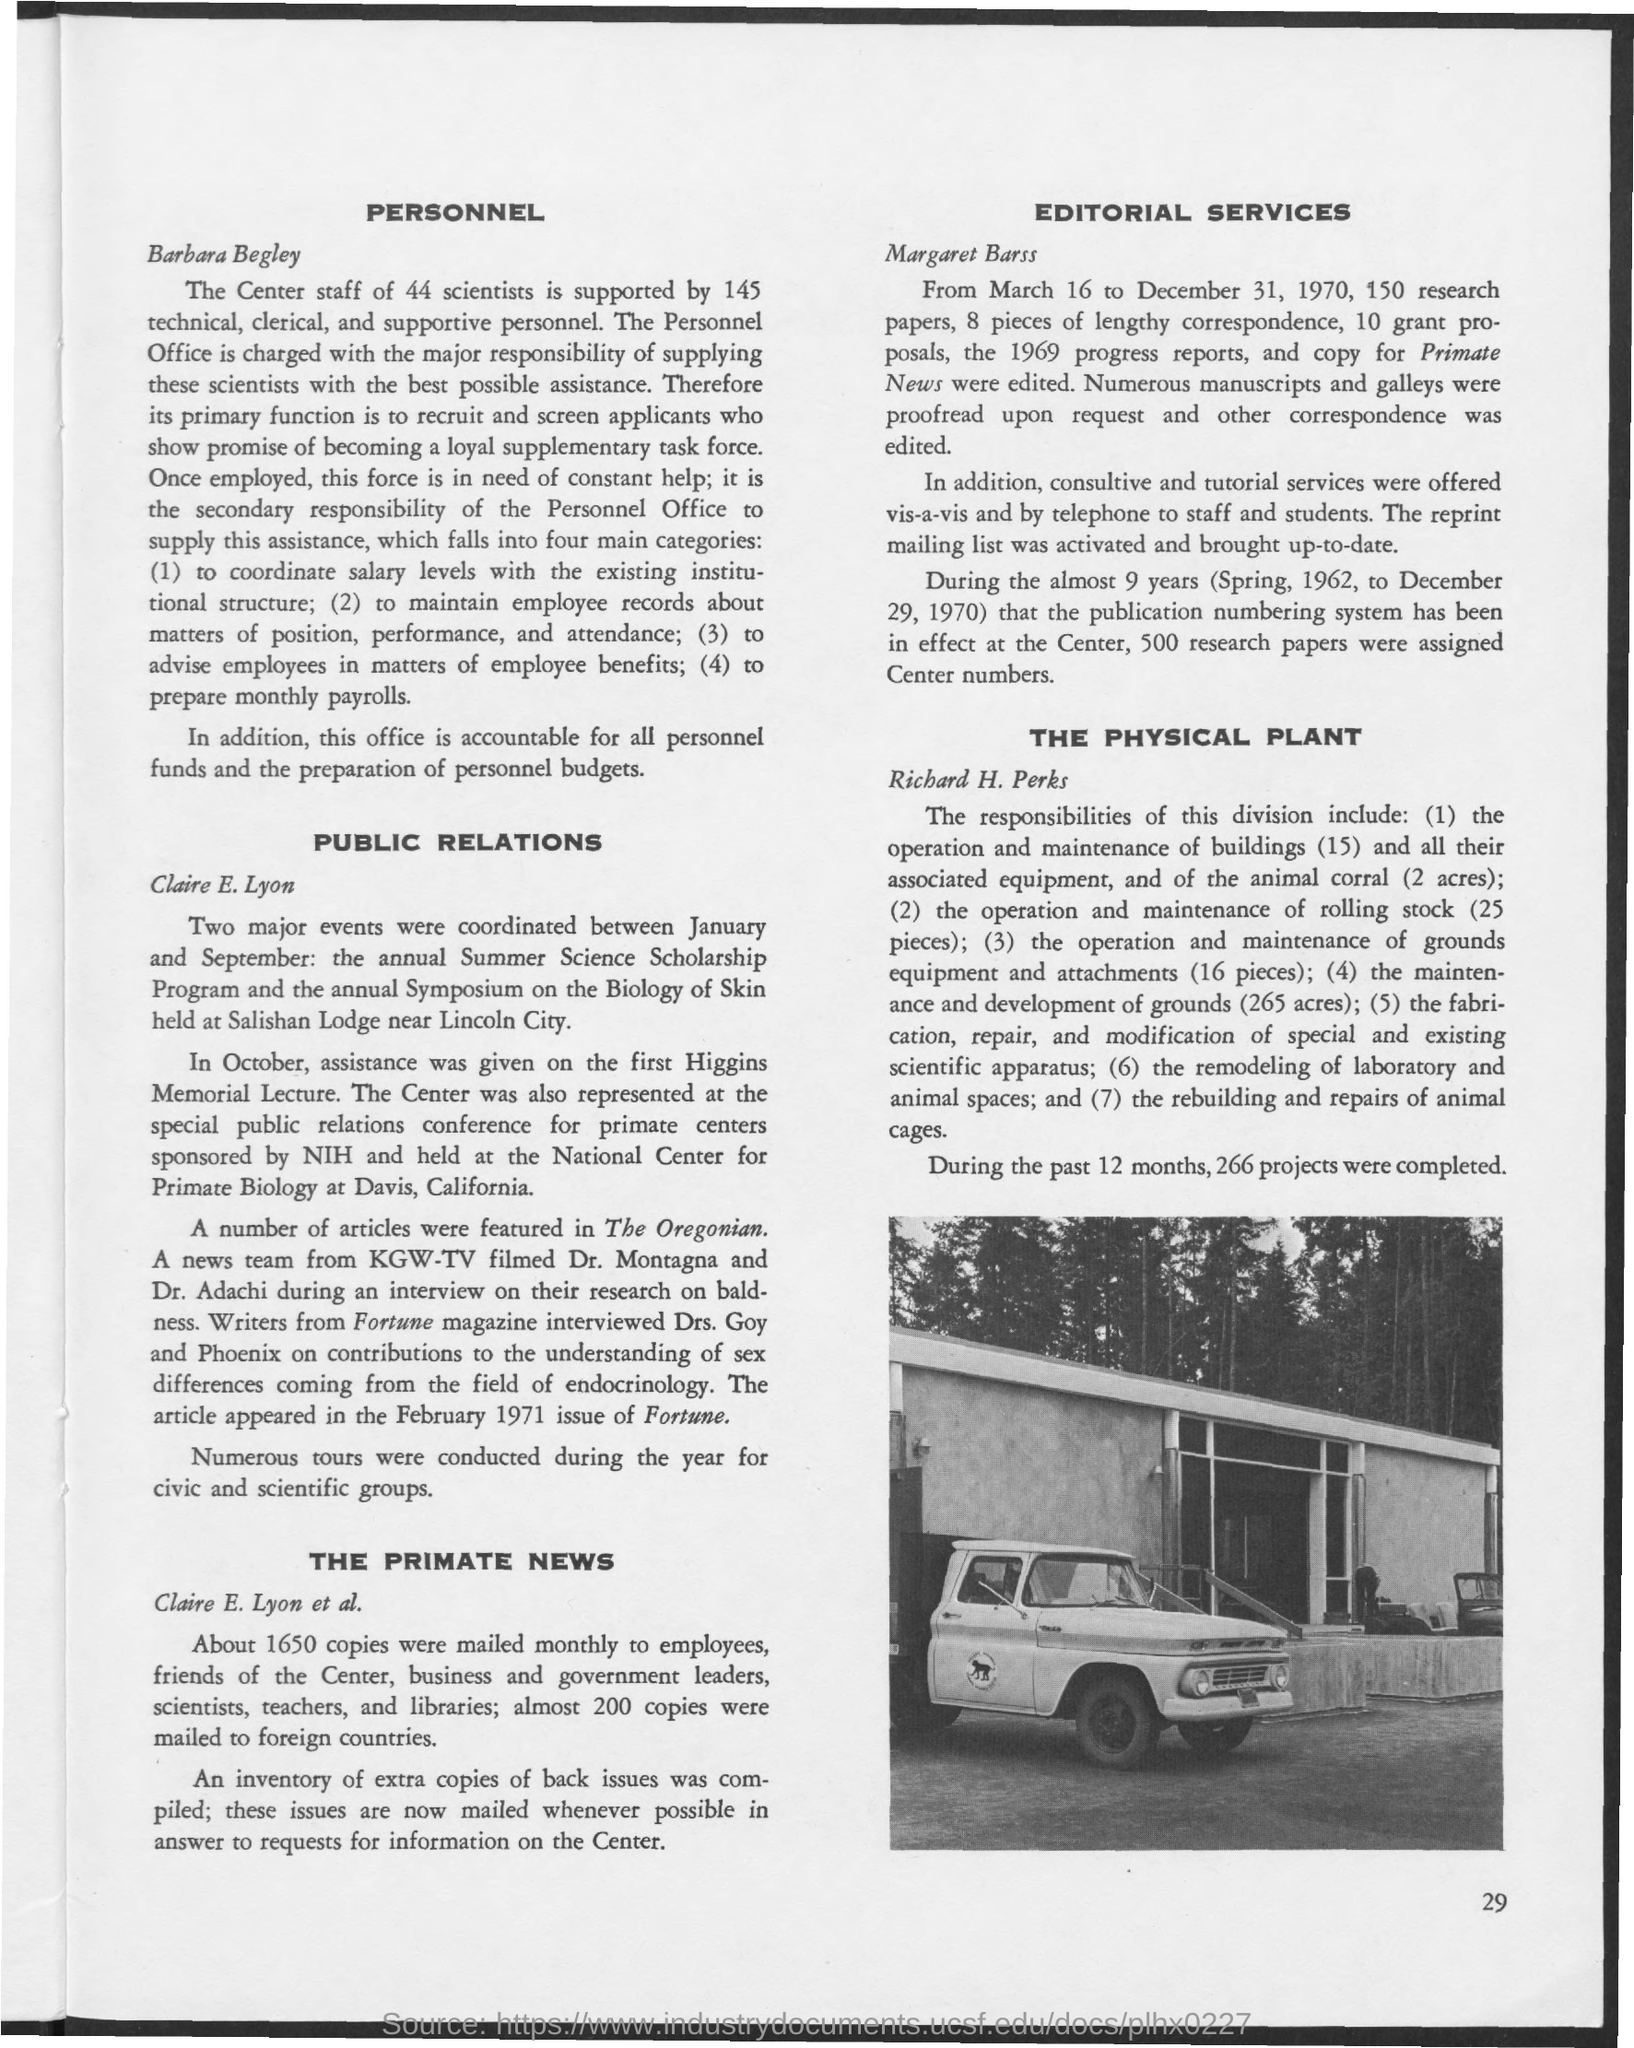What is the page number given at the right bottom corner of the page?
Ensure brevity in your answer.  29. How many scientists are there as "Center staff" under "PERSONNEL"?
Keep it short and to the point. 44. Where is the "annual Symposium on the Biology of Skin held at"?
Your answer should be very brief. Salishan Lodge near Lincoln City. Number of articles about "PUBLIC RELATIONS" were featured in which magazine?
Provide a short and direct response. The Oregonian. Writers from which magazine interviewed "Drs. Goy and Phoenix"?
Give a very brief answer. Fortune Magazine. "EDITORIAL SERVICES" is given by whom?
Offer a very short reply. Margaret Barss. "From March 16 to December 31, 1970" how many research papers were edited?
Ensure brevity in your answer.  150. As mentioned under "THE PHYSICAL PLANT", during the past 12 months,how many projects were completed?
Make the answer very short. 266 projects. 